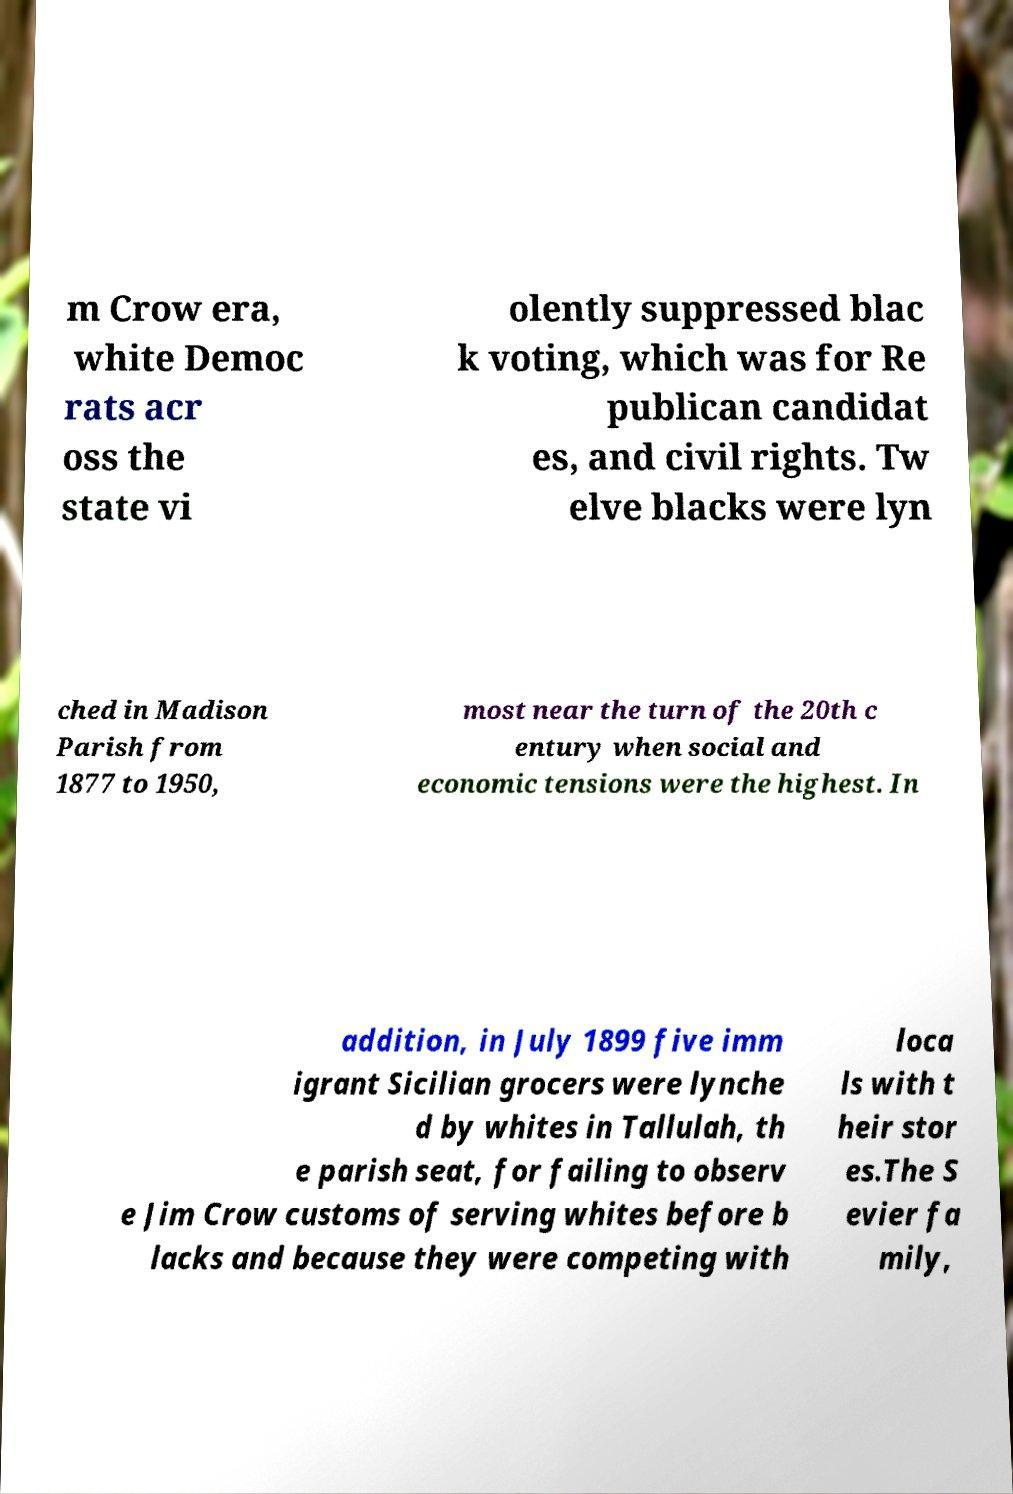Please identify and transcribe the text found in this image. m Crow era, white Democ rats acr oss the state vi olently suppressed blac k voting, which was for Re publican candidat es, and civil rights. Tw elve blacks were lyn ched in Madison Parish from 1877 to 1950, most near the turn of the 20th c entury when social and economic tensions were the highest. In addition, in July 1899 five imm igrant Sicilian grocers were lynche d by whites in Tallulah, th e parish seat, for failing to observ e Jim Crow customs of serving whites before b lacks and because they were competing with loca ls with t heir stor es.The S evier fa mily, 